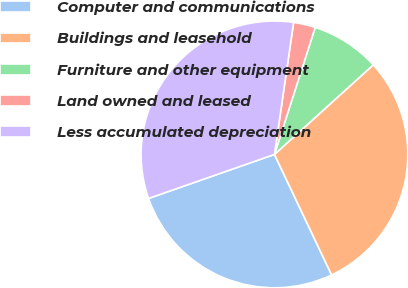Convert chart. <chart><loc_0><loc_0><loc_500><loc_500><pie_chart><fcel>Computer and communications<fcel>Buildings and leasehold<fcel>Furniture and other equipment<fcel>Land owned and leased<fcel>Less accumulated depreciation<nl><fcel>26.69%<fcel>29.67%<fcel>8.34%<fcel>2.65%<fcel>32.65%<nl></chart> 